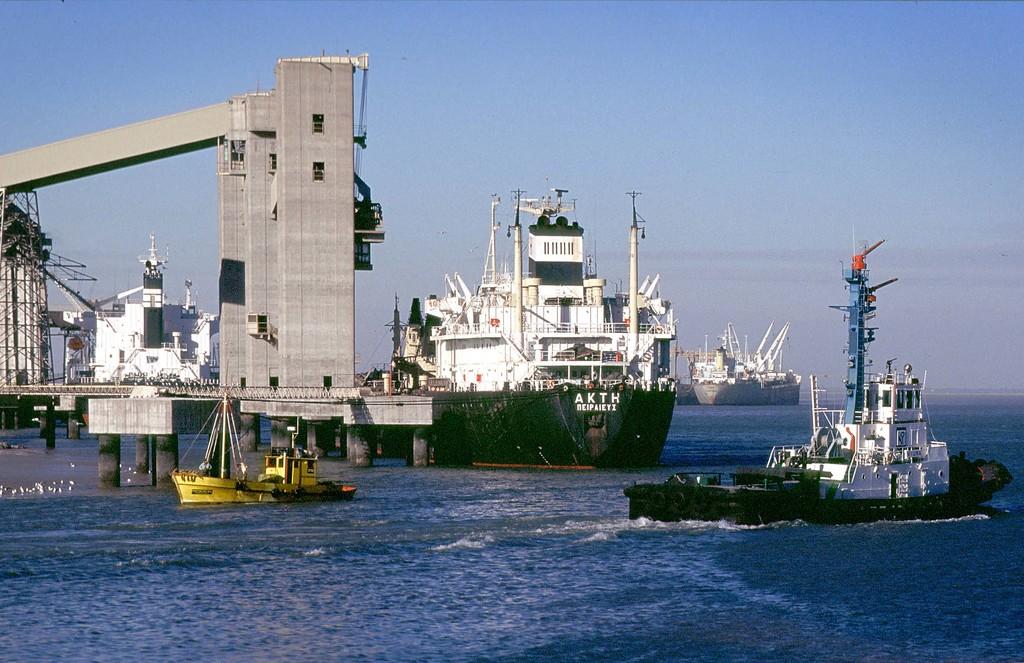Akth is the name of the largest ship, is it docked?
Your response must be concise. Yes. 